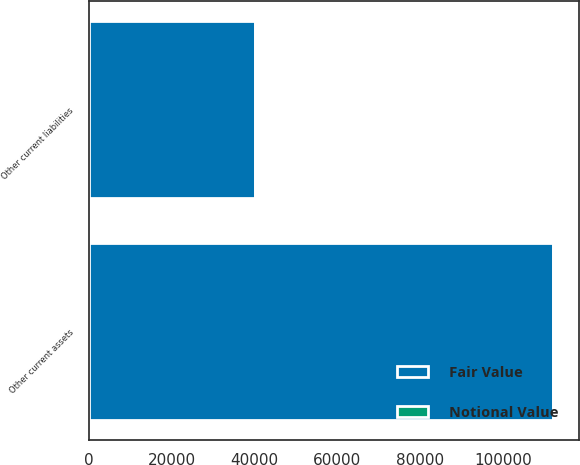Convert chart to OTSL. <chart><loc_0><loc_0><loc_500><loc_500><stacked_bar_chart><ecel><fcel>Other current assets<fcel>Other current liabilities<nl><fcel>Fair Value<fcel>112212<fcel>40175<nl><fcel>Notional Value<fcel>503<fcel>224<nl></chart> 